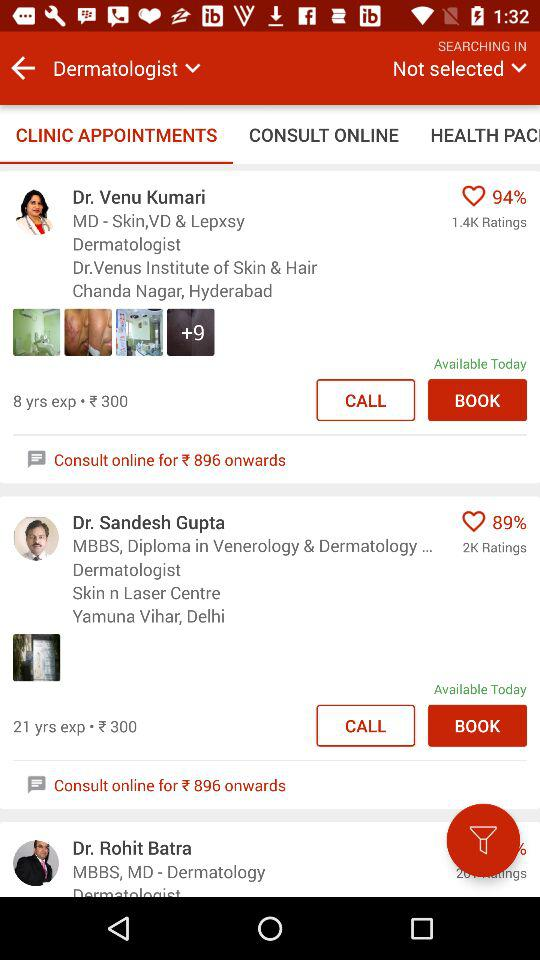Which tab am I on? You are on the "CLINIC APPOINTMENTS" tab. 